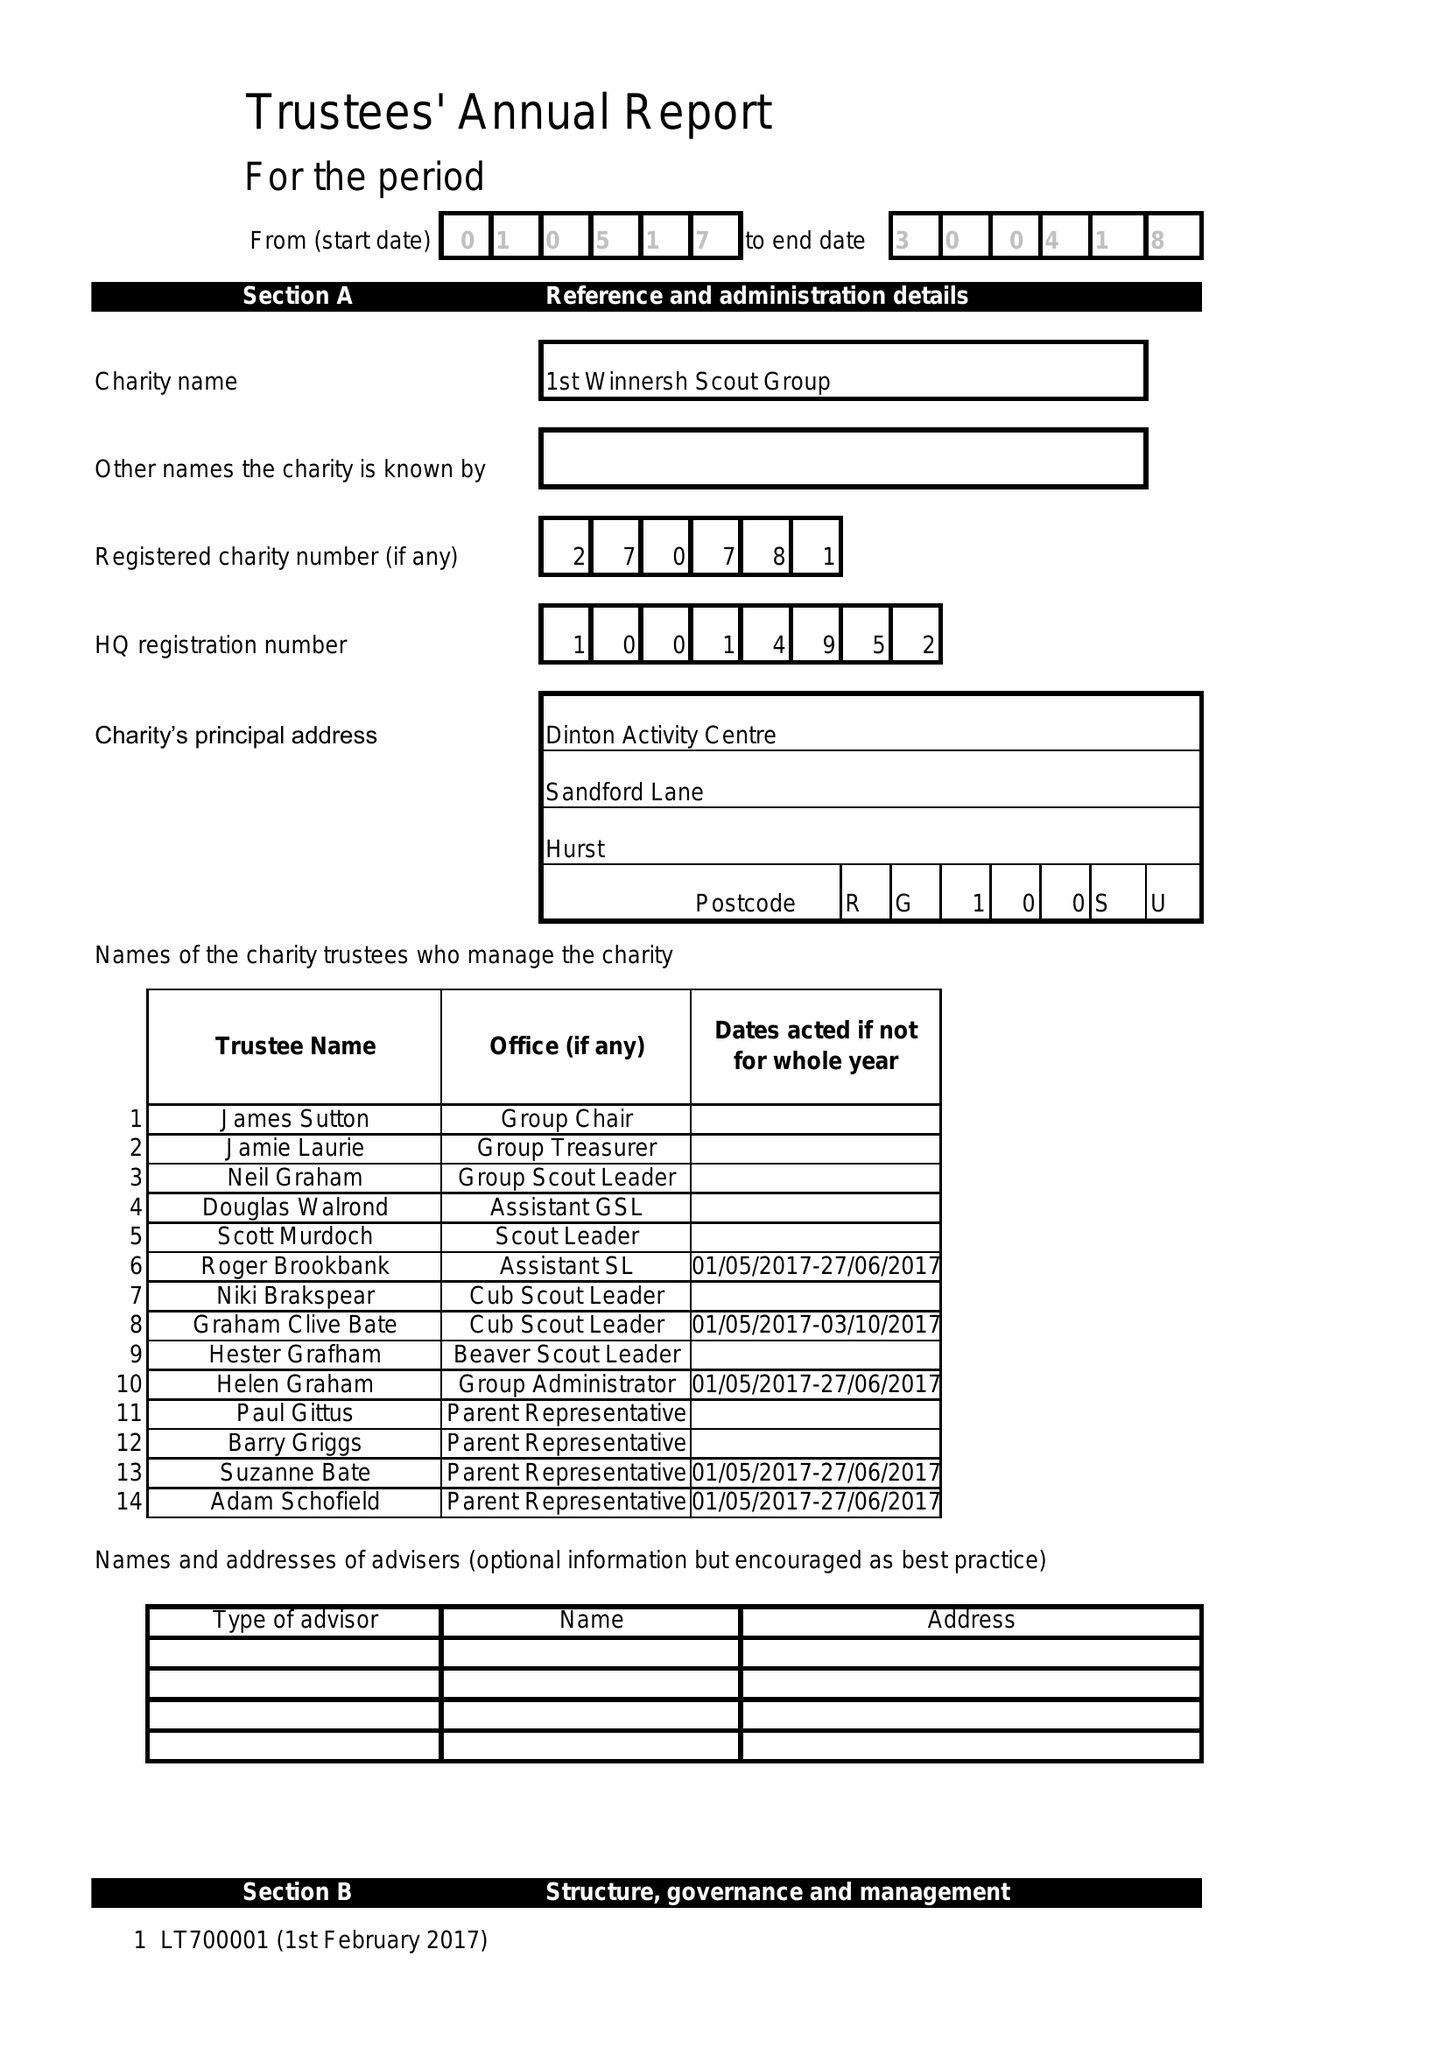What is the value for the charity_name?
Answer the question using a single word or phrase. 1st Winnersh Scout Group 